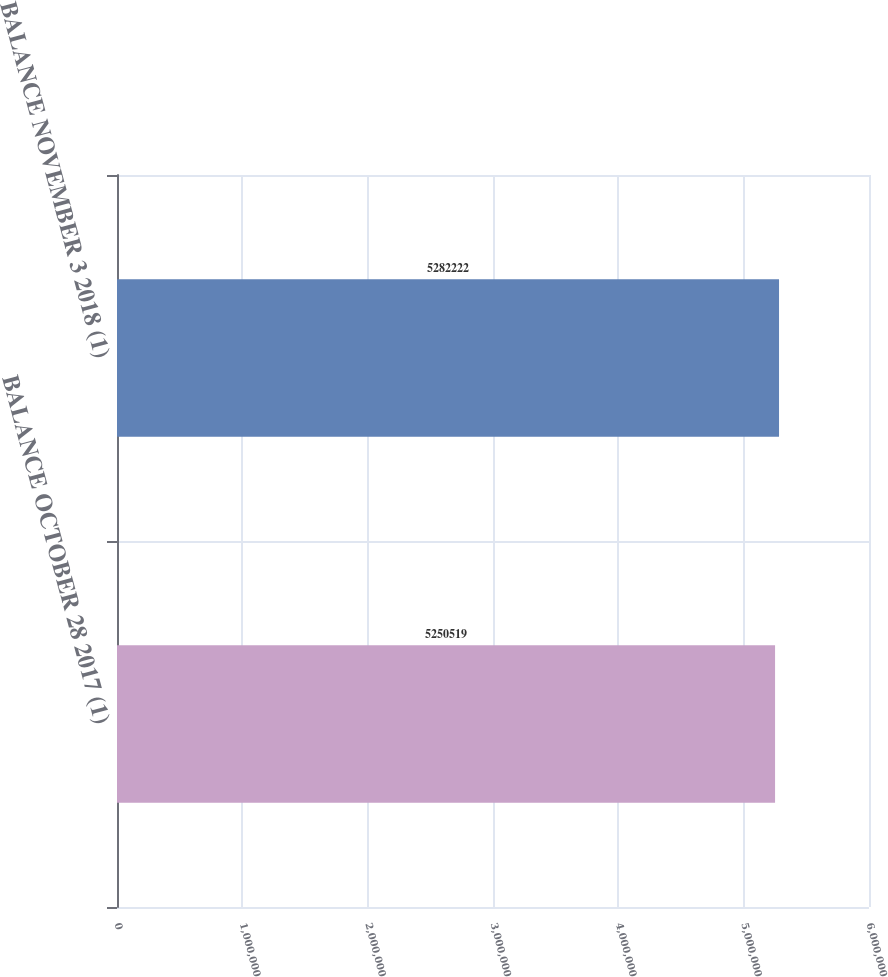Convert chart. <chart><loc_0><loc_0><loc_500><loc_500><bar_chart><fcel>BALANCE OCTOBER 28 2017 (1)<fcel>BALANCE NOVEMBER 3 2018 (1)<nl><fcel>5.25052e+06<fcel>5.28222e+06<nl></chart> 